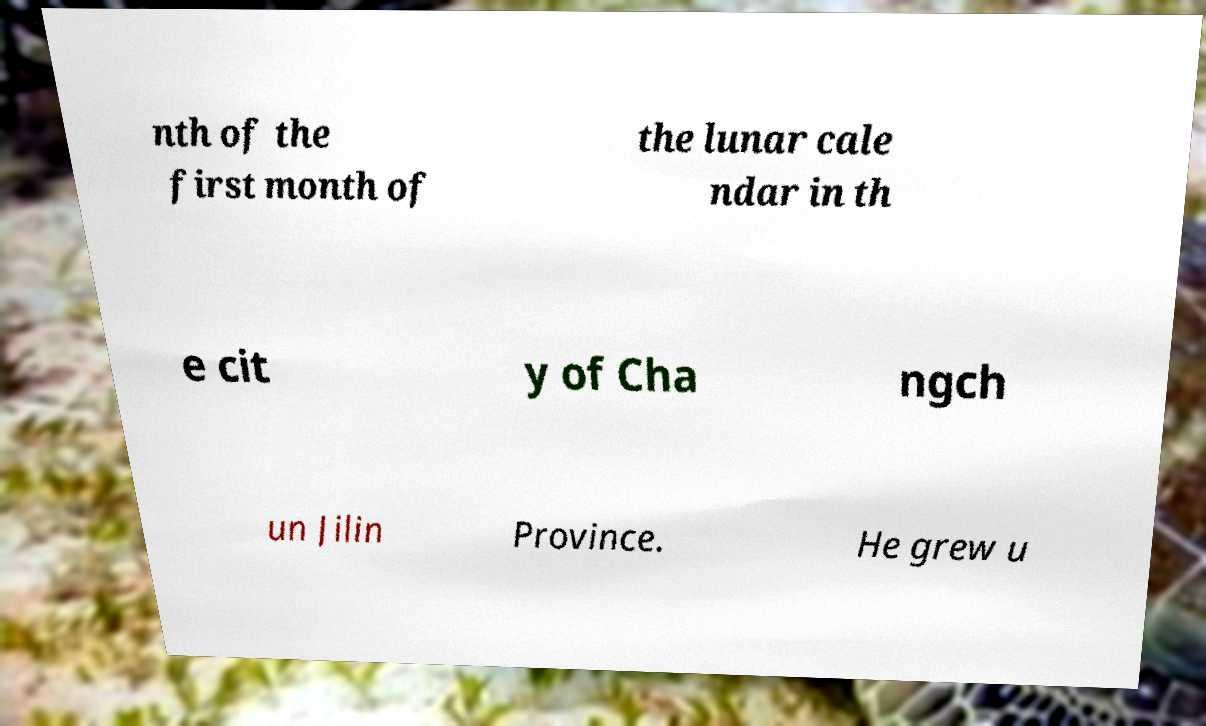Can you read and provide the text displayed in the image?This photo seems to have some interesting text. Can you extract and type it out for me? nth of the first month of the lunar cale ndar in th e cit y of Cha ngch un Jilin Province. He grew u 